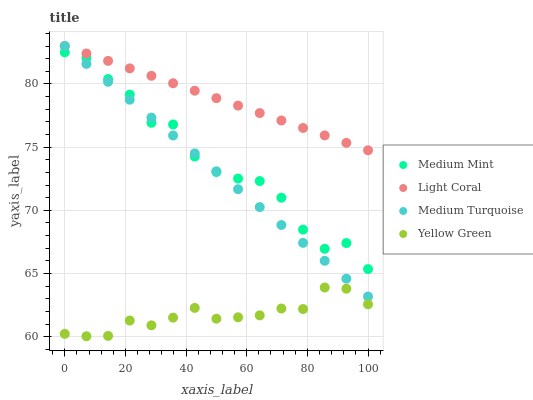Does Yellow Green have the minimum area under the curve?
Answer yes or no. Yes. Does Light Coral have the maximum area under the curve?
Answer yes or no. Yes. Does Light Coral have the minimum area under the curve?
Answer yes or no. No. Does Yellow Green have the maximum area under the curve?
Answer yes or no. No. Is Light Coral the smoothest?
Answer yes or no. Yes. Is Medium Mint the roughest?
Answer yes or no. Yes. Is Yellow Green the smoothest?
Answer yes or no. No. Is Yellow Green the roughest?
Answer yes or no. No. Does Yellow Green have the lowest value?
Answer yes or no. Yes. Does Light Coral have the lowest value?
Answer yes or no. No. Does Medium Turquoise have the highest value?
Answer yes or no. Yes. Does Yellow Green have the highest value?
Answer yes or no. No. Is Yellow Green less than Light Coral?
Answer yes or no. Yes. Is Medium Mint greater than Yellow Green?
Answer yes or no. Yes. Does Medium Turquoise intersect Medium Mint?
Answer yes or no. Yes. Is Medium Turquoise less than Medium Mint?
Answer yes or no. No. Is Medium Turquoise greater than Medium Mint?
Answer yes or no. No. Does Yellow Green intersect Light Coral?
Answer yes or no. No. 